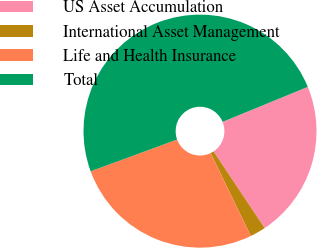<chart> <loc_0><loc_0><loc_500><loc_500><pie_chart><fcel>US Asset Accumulation<fcel>International Asset Management<fcel>Life and Health Insurance<fcel>Total<nl><fcel>21.85%<fcel>2.18%<fcel>26.58%<fcel>49.4%<nl></chart> 